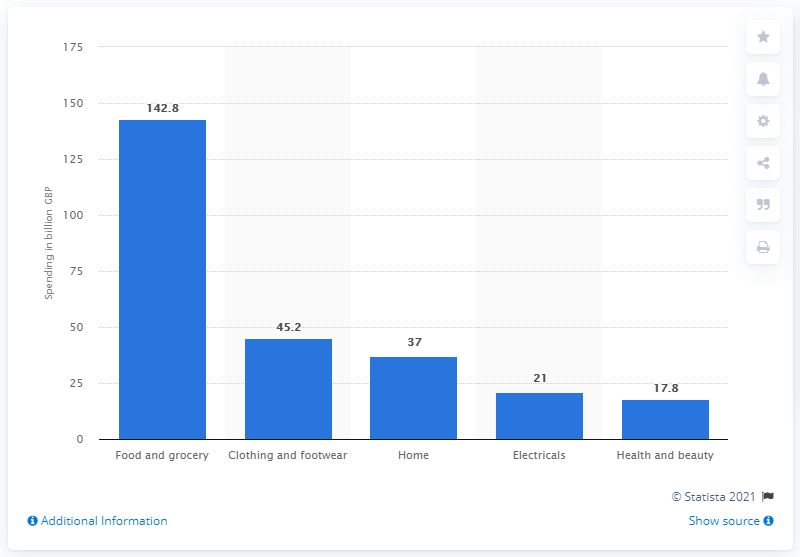Indicate a few pertinent items in this graphic. In 2013, the value of the food and grocery market was 142.8 billion dollars. According to the data, the total spend in the clothing and footwear market in 2013 was 45.2 billion dollars. 